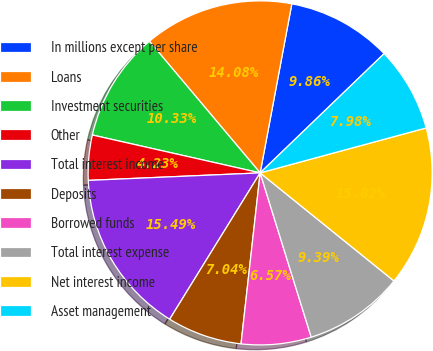<chart> <loc_0><loc_0><loc_500><loc_500><pie_chart><fcel>In millions except per share<fcel>Loans<fcel>Investment securities<fcel>Other<fcel>Total interest income<fcel>Deposits<fcel>Borrowed funds<fcel>Total interest expense<fcel>Net interest income<fcel>Asset management<nl><fcel>9.86%<fcel>14.08%<fcel>10.33%<fcel>4.23%<fcel>15.49%<fcel>7.04%<fcel>6.57%<fcel>9.39%<fcel>15.02%<fcel>7.98%<nl></chart> 